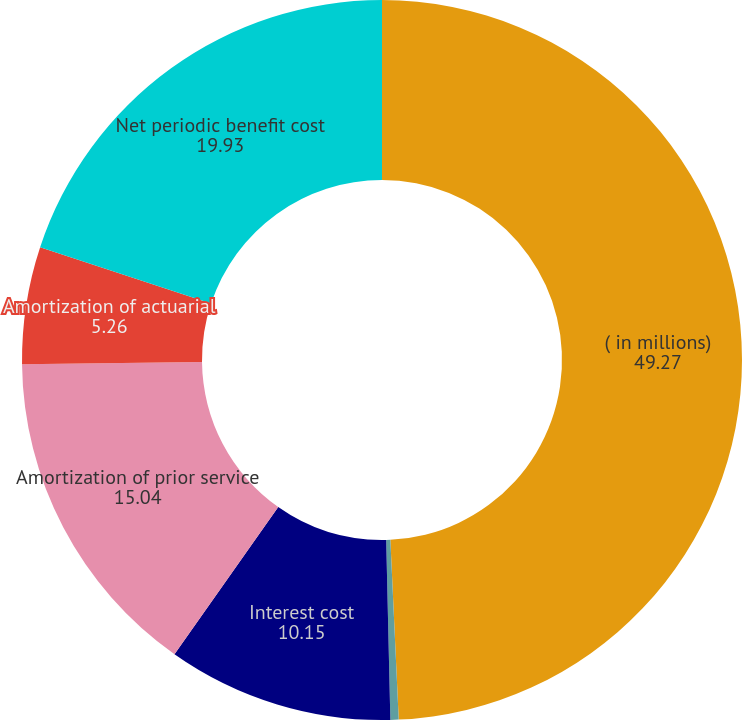Convert chart to OTSL. <chart><loc_0><loc_0><loc_500><loc_500><pie_chart><fcel>( in millions)<fcel>Service cost<fcel>Interest cost<fcel>Amortization of prior service<fcel>Amortization of actuarial<fcel>Net periodic benefit cost<nl><fcel>49.27%<fcel>0.37%<fcel>10.15%<fcel>15.04%<fcel>5.26%<fcel>19.93%<nl></chart> 